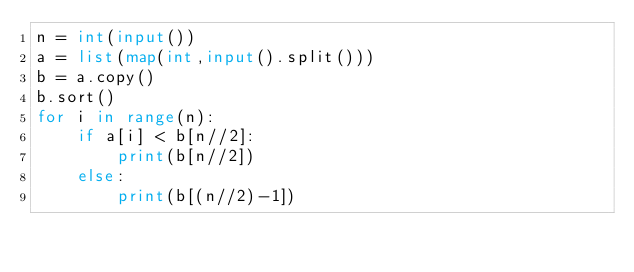Convert code to text. <code><loc_0><loc_0><loc_500><loc_500><_Python_>n = int(input())
a = list(map(int,input().split()))
b = a.copy()
b.sort()
for i in range(n):
    if a[i] < b[n//2]:
        print(b[n//2])
    else:
        print(b[(n//2)-1])</code> 